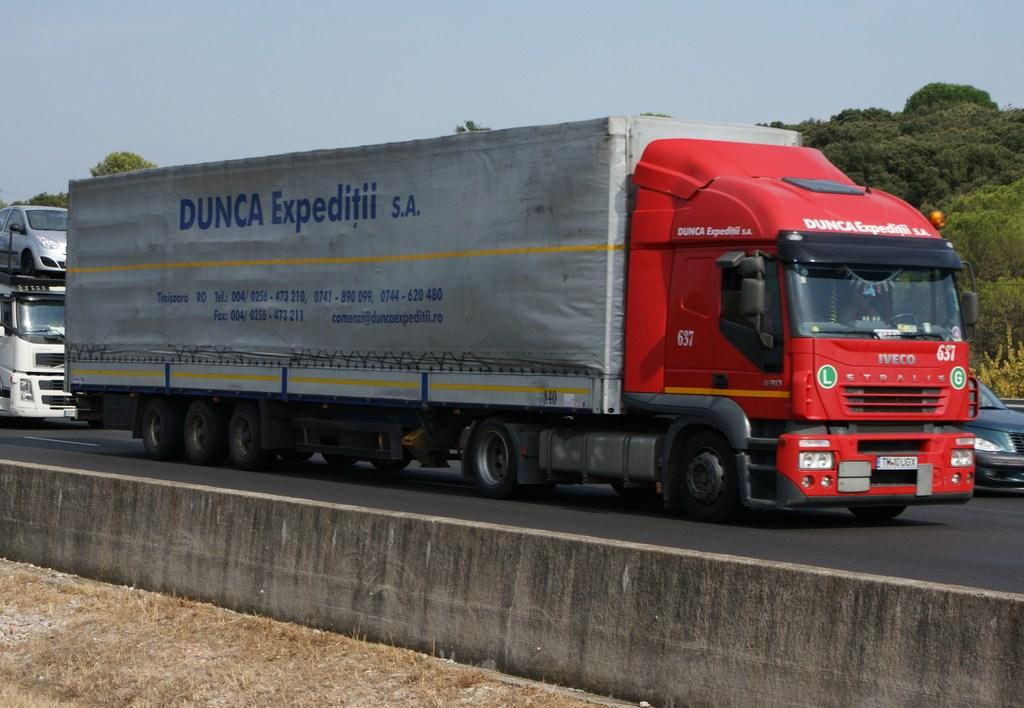What is the main subject in the center of the image? There is a truck in the center of the image. Where is the truck located? The truck is on the road. Are there any other vehicles in the image? Yes, there are other vehicles in the image. What can be seen in the background of the image? There are trees in the background of the image. Can you see your dad driving the truck in the image? There is no mention of a dad or anyone driving the truck in the image. The image only shows a truck on the road with other vehicles and trees in the background. 